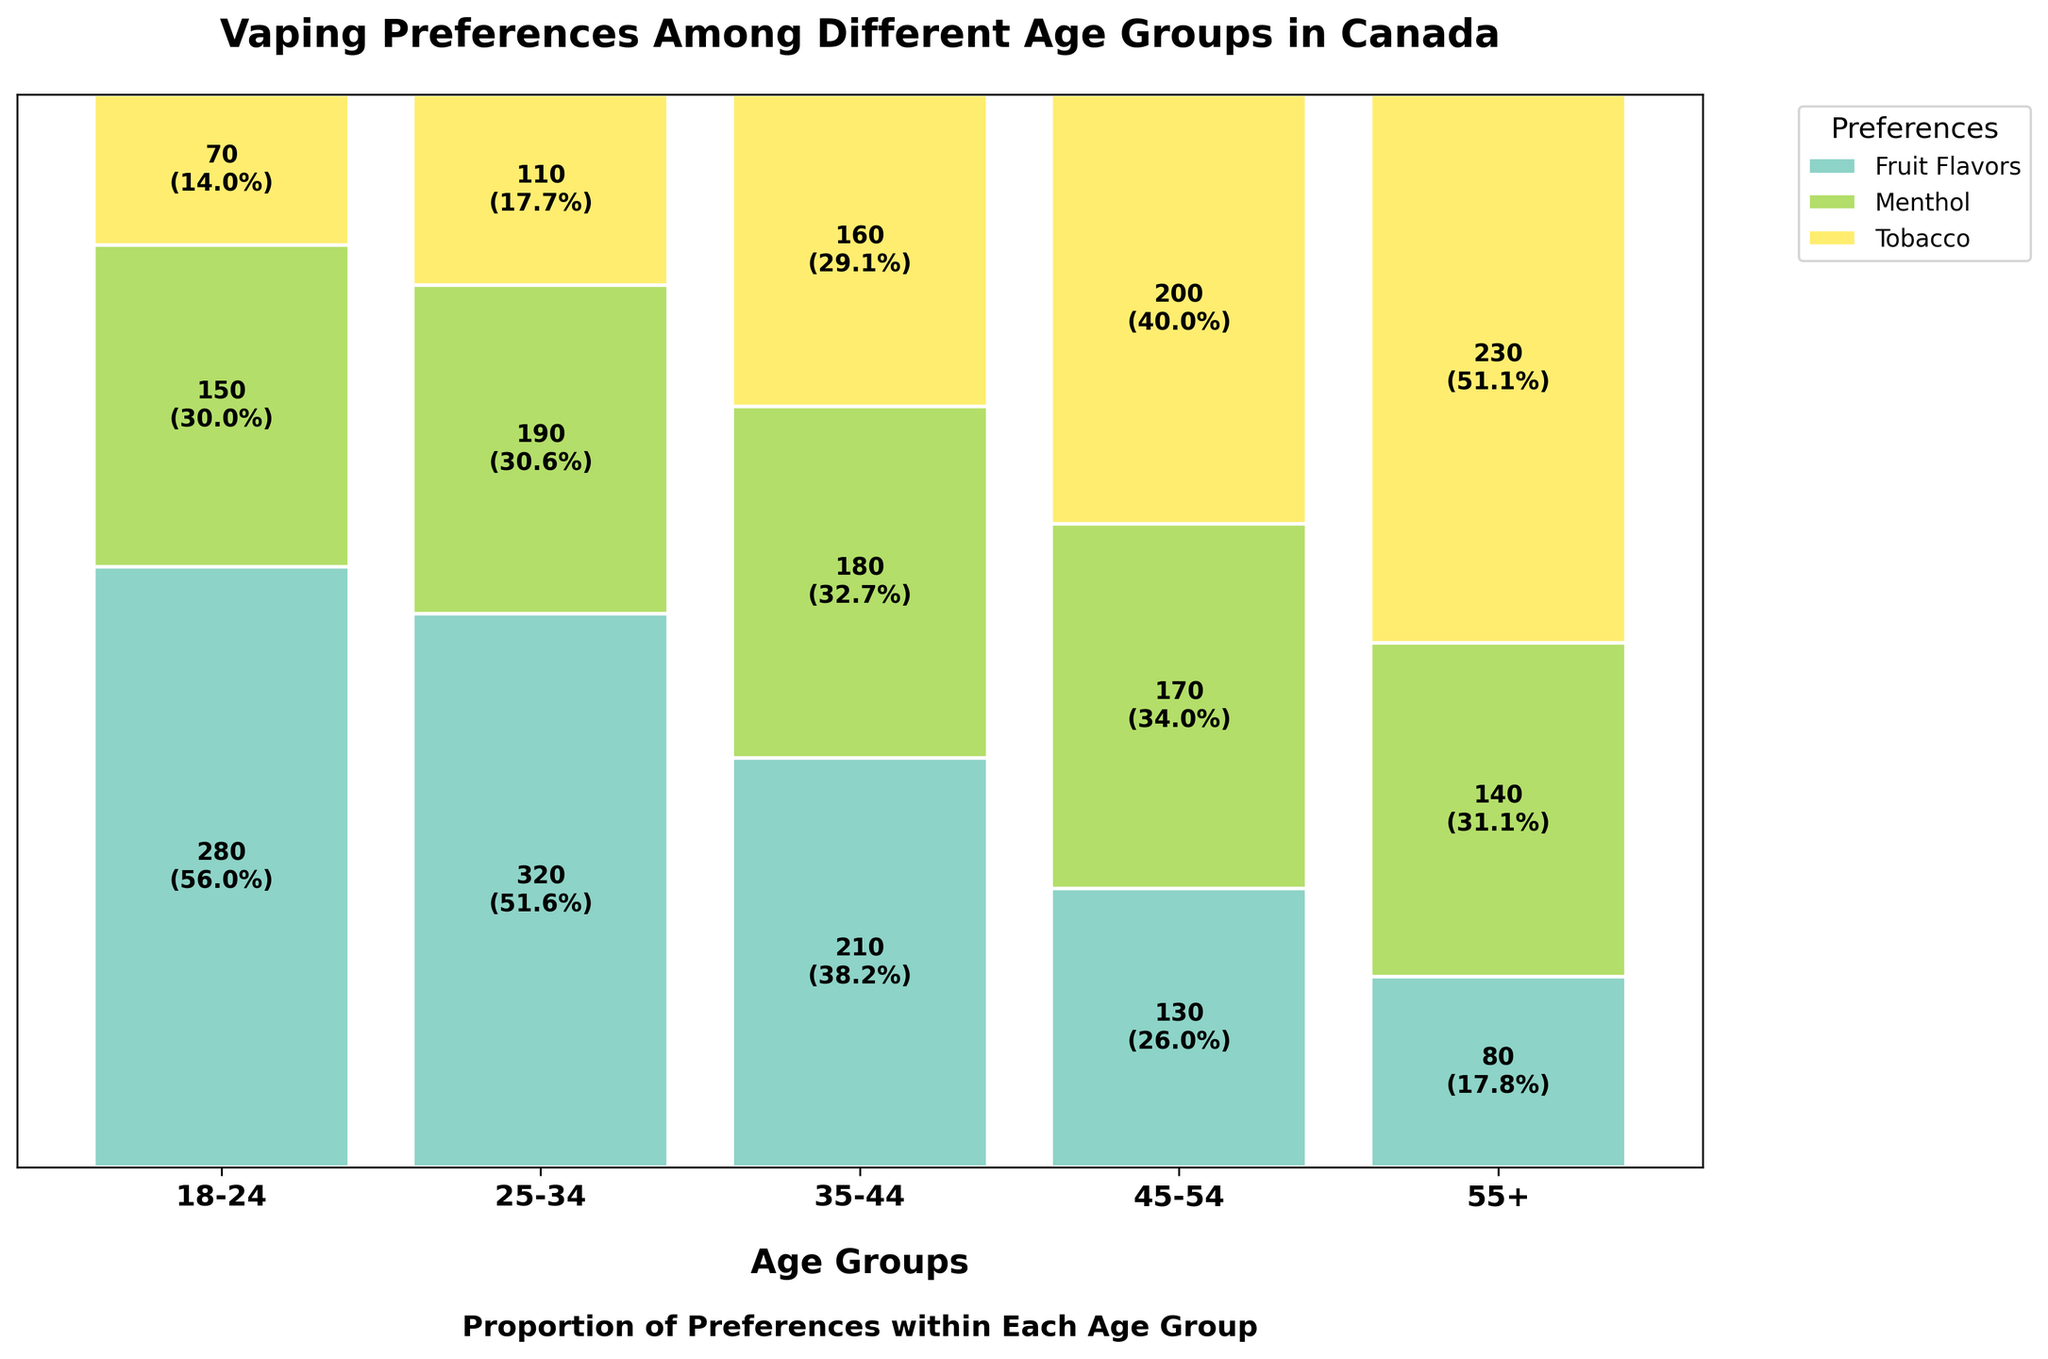What is the most popular flavor among the 18-24 age group? The height of the Fruit Flavors segment in the Mosaic Plot for the 18-24 age group is the highest, indicating it's the most popular.
Answer: Fruit Flavors What is the total count of people preferring Menthol across all age groups? The counts for Menthol in each age group are 150 (18-24), 190 (25-34), 180 (35-44), 170 (45-54), and 140 (55+). Summing these: 150 + 190 + 180 + 170 + 140 = 830.
Answer: 830 How does the preference for Tobacco change from the 18-24 age group to the 55+ age group? The figure shows that the height of the Tobacco segment increases from 70 in the 18-24 group to 230 in the 55+ group, indicating an increasing preference with age.
Answer: Increases Which age group has the highest preference for Fruit Flavors proportionally? By comparing the height of the Fruit Flavors segments relative to others within each age group, the 25-34 age group has the highest proportional preference.
Answer: 25-34 What is the least popular flavor among the 45-54 age group? The graph shows that the height of the Fruit Flavors segment in the 45-54 age group is the shortest, making it the least popular flavor.
Answer: Fruit Flavors Calculate the percentage of Tobacco preference in the 35-44 age group. The count for Tobacco in the 35-44 age group is 160, and the total for the group is 210 (Fruit) + 180 (Menthol) + 160 (Tobacco) = 550. The percentage is (160/550) * 100 ≈ 29.1%.
Answer: 29.1% How does the proportion of Menthol in the 25-34 age group compare to the 55+ age group? For the 25-34 age group, the Menthol count is 190 out of 620 total (190/620 ≈ 30.6%). For the 55+ group, it's 140 out of 450 total (140/450 ≈ 31.1%). The proportions are close but slightly higher in the 55+ group.
Answer: Slightly higher in 55+ Combine the heights of the Fruit Flavors and Menthol segments for the 18-24 age group. What value does this represent? The heights (counts) for Fruit Flavors and Menthol in the 18-24 age group are 280 and 150. Combining them: 280 + 150 = 430.
Answer: 430 Which age group displays the most even distribution among the three preferences? Observing the balanced heights of the segments, the 45-54 age group shows a relatively even distribution among Fruit Flavors, Menthol, and Tobacco.
Answer: 45-54 